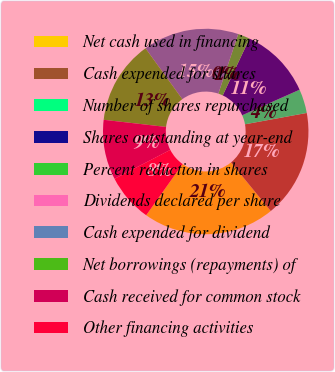<chart> <loc_0><loc_0><loc_500><loc_500><pie_chart><fcel>Net cash used in financing<fcel>Cash expended for shares<fcel>Number of shares repurchased<fcel>Shares outstanding at year-end<fcel>Percent reduction in shares<fcel>Dividends declared per share<fcel>Cash expended for dividend<fcel>Net borrowings (repayments) of<fcel>Cash received for common stock<fcel>Other financing activities<nl><fcel>20.75%<fcel>16.98%<fcel>3.78%<fcel>11.32%<fcel>1.89%<fcel>0.0%<fcel>15.09%<fcel>13.21%<fcel>9.43%<fcel>7.55%<nl></chart> 